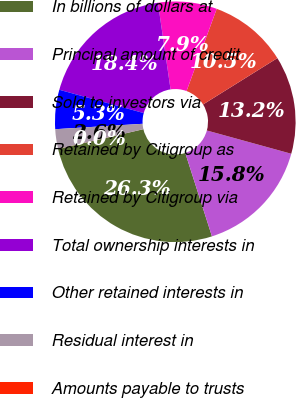Convert chart to OTSL. <chart><loc_0><loc_0><loc_500><loc_500><pie_chart><fcel>In billions of dollars at<fcel>Principal amount of credit<fcel>Sold to investors via<fcel>Retained by Citigroup as<fcel>Retained by Citigroup via<fcel>Total ownership interests in<fcel>Other retained interests in<fcel>Residual interest in<fcel>Amounts payable to trusts<nl><fcel>26.3%<fcel>15.79%<fcel>13.16%<fcel>10.53%<fcel>7.9%<fcel>18.41%<fcel>5.27%<fcel>2.64%<fcel>0.01%<nl></chart> 